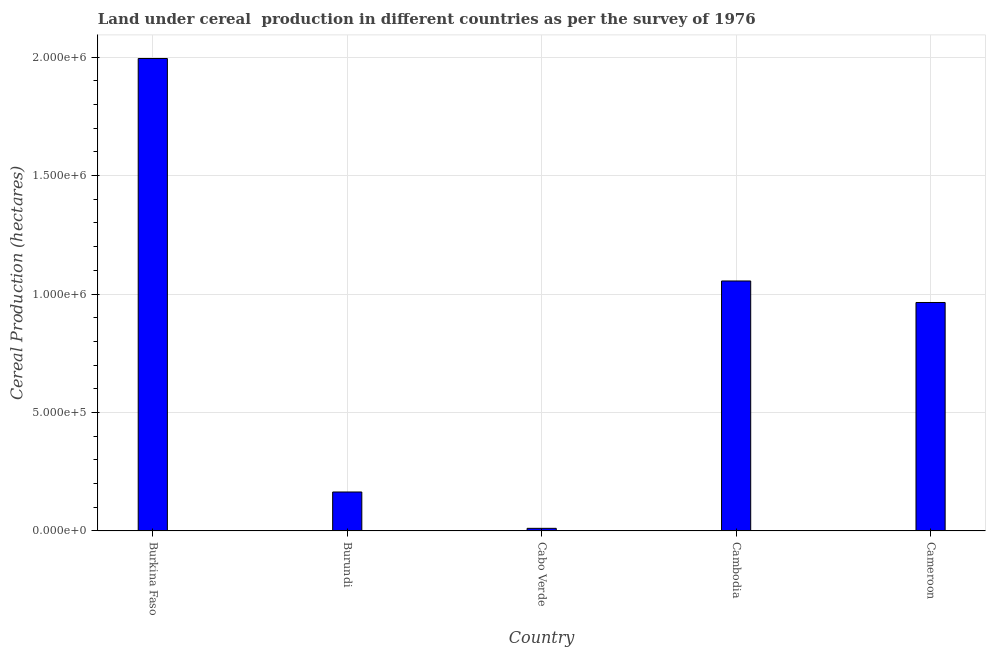What is the title of the graph?
Make the answer very short. Land under cereal  production in different countries as per the survey of 1976. What is the label or title of the Y-axis?
Make the answer very short. Cereal Production (hectares). What is the land under cereal production in Cabo Verde?
Offer a very short reply. 1.10e+04. Across all countries, what is the maximum land under cereal production?
Provide a short and direct response. 1.99e+06. Across all countries, what is the minimum land under cereal production?
Ensure brevity in your answer.  1.10e+04. In which country was the land under cereal production maximum?
Make the answer very short. Burkina Faso. In which country was the land under cereal production minimum?
Ensure brevity in your answer.  Cabo Verde. What is the sum of the land under cereal production?
Your response must be concise. 4.19e+06. What is the difference between the land under cereal production in Burkina Faso and Cabo Verde?
Your answer should be very brief. 1.98e+06. What is the average land under cereal production per country?
Your answer should be very brief. 8.38e+05. What is the median land under cereal production?
Keep it short and to the point. 9.64e+05. In how many countries, is the land under cereal production greater than 300000 hectares?
Provide a short and direct response. 3. What is the ratio of the land under cereal production in Burkina Faso to that in Cabo Verde?
Your response must be concise. 181.27. What is the difference between the highest and the second highest land under cereal production?
Provide a short and direct response. 9.39e+05. What is the difference between the highest and the lowest land under cereal production?
Your response must be concise. 1.98e+06. In how many countries, is the land under cereal production greater than the average land under cereal production taken over all countries?
Offer a very short reply. 3. How many bars are there?
Keep it short and to the point. 5. Are all the bars in the graph horizontal?
Ensure brevity in your answer.  No. How many countries are there in the graph?
Your response must be concise. 5. What is the difference between two consecutive major ticks on the Y-axis?
Your answer should be very brief. 5.00e+05. What is the Cereal Production (hectares) in Burkina Faso?
Offer a terse response. 1.99e+06. What is the Cereal Production (hectares) in Burundi?
Ensure brevity in your answer.  1.64e+05. What is the Cereal Production (hectares) in Cabo Verde?
Ensure brevity in your answer.  1.10e+04. What is the Cereal Production (hectares) in Cambodia?
Give a very brief answer. 1.06e+06. What is the Cereal Production (hectares) in Cameroon?
Ensure brevity in your answer.  9.64e+05. What is the difference between the Cereal Production (hectares) in Burkina Faso and Burundi?
Offer a terse response. 1.83e+06. What is the difference between the Cereal Production (hectares) in Burkina Faso and Cabo Verde?
Your response must be concise. 1.98e+06. What is the difference between the Cereal Production (hectares) in Burkina Faso and Cambodia?
Offer a very short reply. 9.39e+05. What is the difference between the Cereal Production (hectares) in Burkina Faso and Cameroon?
Your answer should be very brief. 1.03e+06. What is the difference between the Cereal Production (hectares) in Burundi and Cabo Verde?
Keep it short and to the point. 1.53e+05. What is the difference between the Cereal Production (hectares) in Burundi and Cambodia?
Your answer should be very brief. -8.91e+05. What is the difference between the Cereal Production (hectares) in Burundi and Cameroon?
Offer a terse response. -8.00e+05. What is the difference between the Cereal Production (hectares) in Cabo Verde and Cambodia?
Ensure brevity in your answer.  -1.04e+06. What is the difference between the Cereal Production (hectares) in Cabo Verde and Cameroon?
Your answer should be compact. -9.53e+05. What is the difference between the Cereal Production (hectares) in Cambodia and Cameroon?
Keep it short and to the point. 9.08e+04. What is the ratio of the Cereal Production (hectares) in Burkina Faso to that in Burundi?
Your answer should be very brief. 12.13. What is the ratio of the Cereal Production (hectares) in Burkina Faso to that in Cabo Verde?
Keep it short and to the point. 181.27. What is the ratio of the Cereal Production (hectares) in Burkina Faso to that in Cambodia?
Make the answer very short. 1.89. What is the ratio of the Cereal Production (hectares) in Burkina Faso to that in Cameroon?
Your answer should be compact. 2.07. What is the ratio of the Cereal Production (hectares) in Burundi to that in Cabo Verde?
Make the answer very short. 14.94. What is the ratio of the Cereal Production (hectares) in Burundi to that in Cambodia?
Give a very brief answer. 0.16. What is the ratio of the Cereal Production (hectares) in Burundi to that in Cameroon?
Ensure brevity in your answer.  0.17. What is the ratio of the Cereal Production (hectares) in Cabo Verde to that in Cameroon?
Make the answer very short. 0.01. What is the ratio of the Cereal Production (hectares) in Cambodia to that in Cameroon?
Provide a short and direct response. 1.09. 